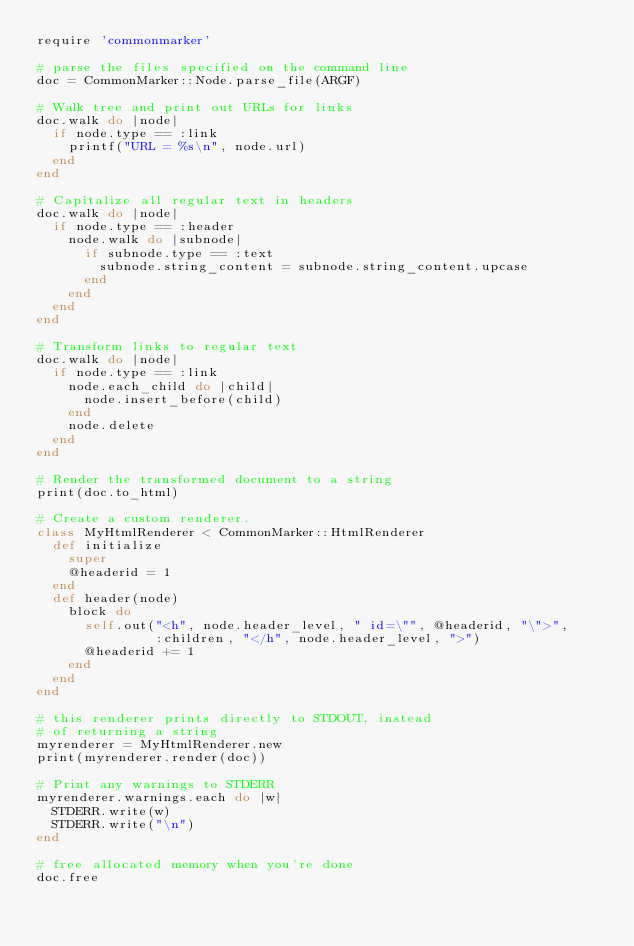<code> <loc_0><loc_0><loc_500><loc_500><_Ruby_>require 'commonmarker'

# parse the files specified on the command line
doc = CommonMarker::Node.parse_file(ARGF)

# Walk tree and print out URLs for links
doc.walk do |node|
  if node.type == :link
    printf("URL = %s\n", node.url)
  end
end

# Capitalize all regular text in headers
doc.walk do |node|
  if node.type == :header
    node.walk do |subnode|
      if subnode.type == :text
        subnode.string_content = subnode.string_content.upcase
      end
    end
  end
end

# Transform links to regular text
doc.walk do |node|
  if node.type == :link
    node.each_child do |child|
      node.insert_before(child)
    end
    node.delete
  end
end

# Render the transformed document to a string
print(doc.to_html)

# Create a custom renderer.
class MyHtmlRenderer < CommonMarker::HtmlRenderer
  def initialize
    super
    @headerid = 1
  end
  def header(node)
    block do
      self.out("<h", node.header_level, " id=\"", @headerid, "\">",
               :children, "</h", node.header_level, ">")
      @headerid += 1
    end
  end
end

# this renderer prints directly to STDOUT, instead
# of returning a string
myrenderer = MyHtmlRenderer.new
print(myrenderer.render(doc))

# Print any warnings to STDERR
myrenderer.warnings.each do |w|
  STDERR.write(w)
  STDERR.write("\n")
end

# free allocated memory when you're done
doc.free
</code> 